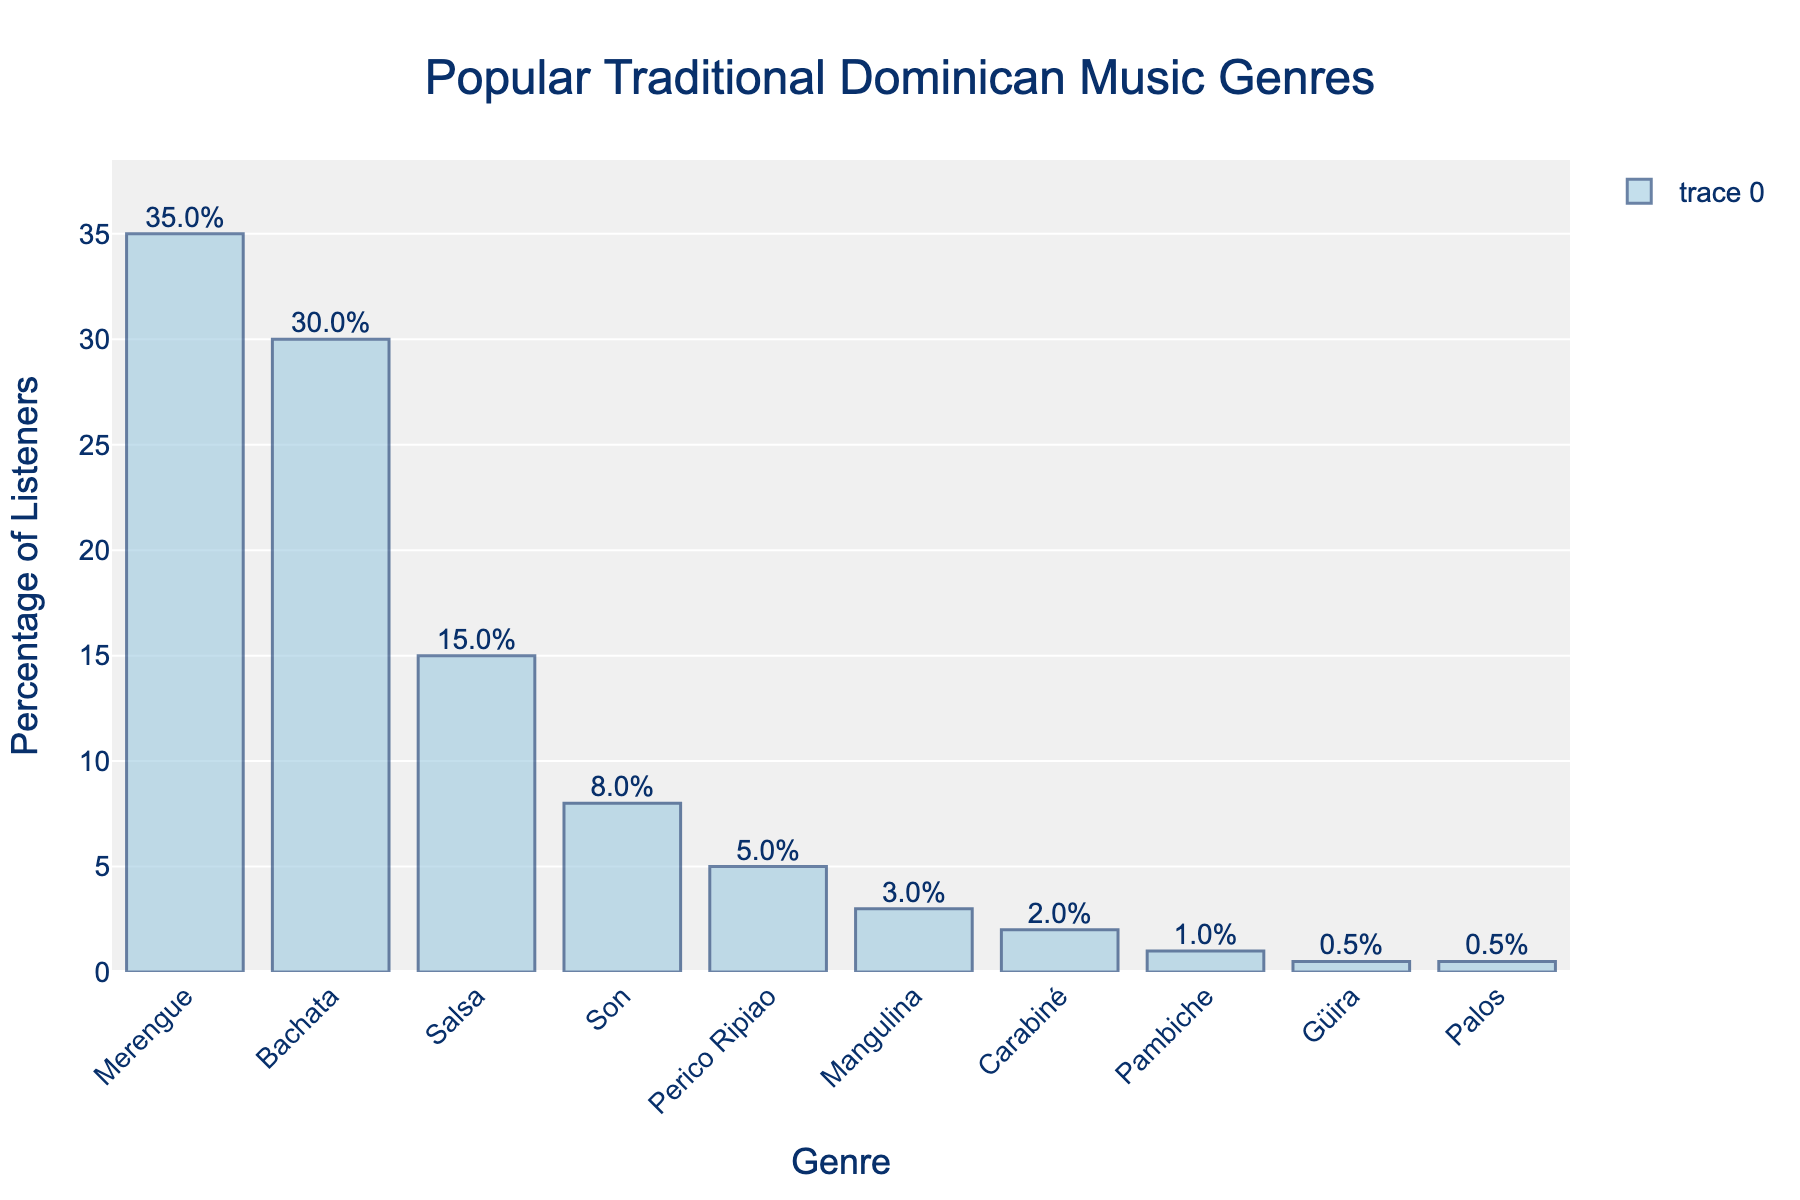What's the most popular Dominican music genre? The genre with the highest bar represents the most popular genre. Merengue has the highest bar with 35% of listeners.
Answer: Merengue Which genres have less than 5% of listeners? Look for the bars that represent less than 5% on the y-axis. Perico Ripiao, Mangulina, Carabiné, Pambiche, Güira, and Palos fall into this category.
Answer: Perico Ripiao, Mangulina, Carabiné, Pambiche, Güira, Palos What is the combined percentage of listeners for Bachata and Salsa? Add the percentage of listeners for Bachata (30%) and Salsa (15%). Bachata (30%) + Salsa (15%) = 45%.
Answer: 45% How much more popular is Merengue than Perico Ripiao? Subtract the percentage of listeners for Perico Ripiao (5%) from Merengue (35%). 35% - 5% = 30%.
Answer: 30% Which genre has the smallest percentage of listeners? The smallest bar represents the least popular genre. Güira and Palos both have the smallest bar with 0.5% each.
Answer: Güira, Palos Compare the popularity of Son and Pambiche. The bar for Son is at 8%, while the bar for Pambiche is at 1%. Son is more popular.
Answer: Son is more popular Is there a significant difference between the percentage of listeners for Merengue and Bachata? Subtract the percentage of listeners for Bachata (30%) from Merengue (35%). 35% - 30% = 5%, which is a noticeable difference.
Answer: Yes, 5% What is the mean percentage of listeners for Palos, Carabiné, and Pambiche? Add the percentages of these genres and divide by the number of genres (3). (0.5% + 2% + 1%) / 3 = 1.17%.
Answer: 1.17% Which genre's bar stands around the middle height visually? Identify the genre whose bar seems in the center heightwise between the tallest and shortest bars. Salsa stands around midway with 15%.
Answer: Salsa What is the difference in popularity between the second and third most popular genres? Subtract the percentage of listeners for Salsa (15%) from Bachata (30%). 30% - 15% = 15%.
Answer: 15% 